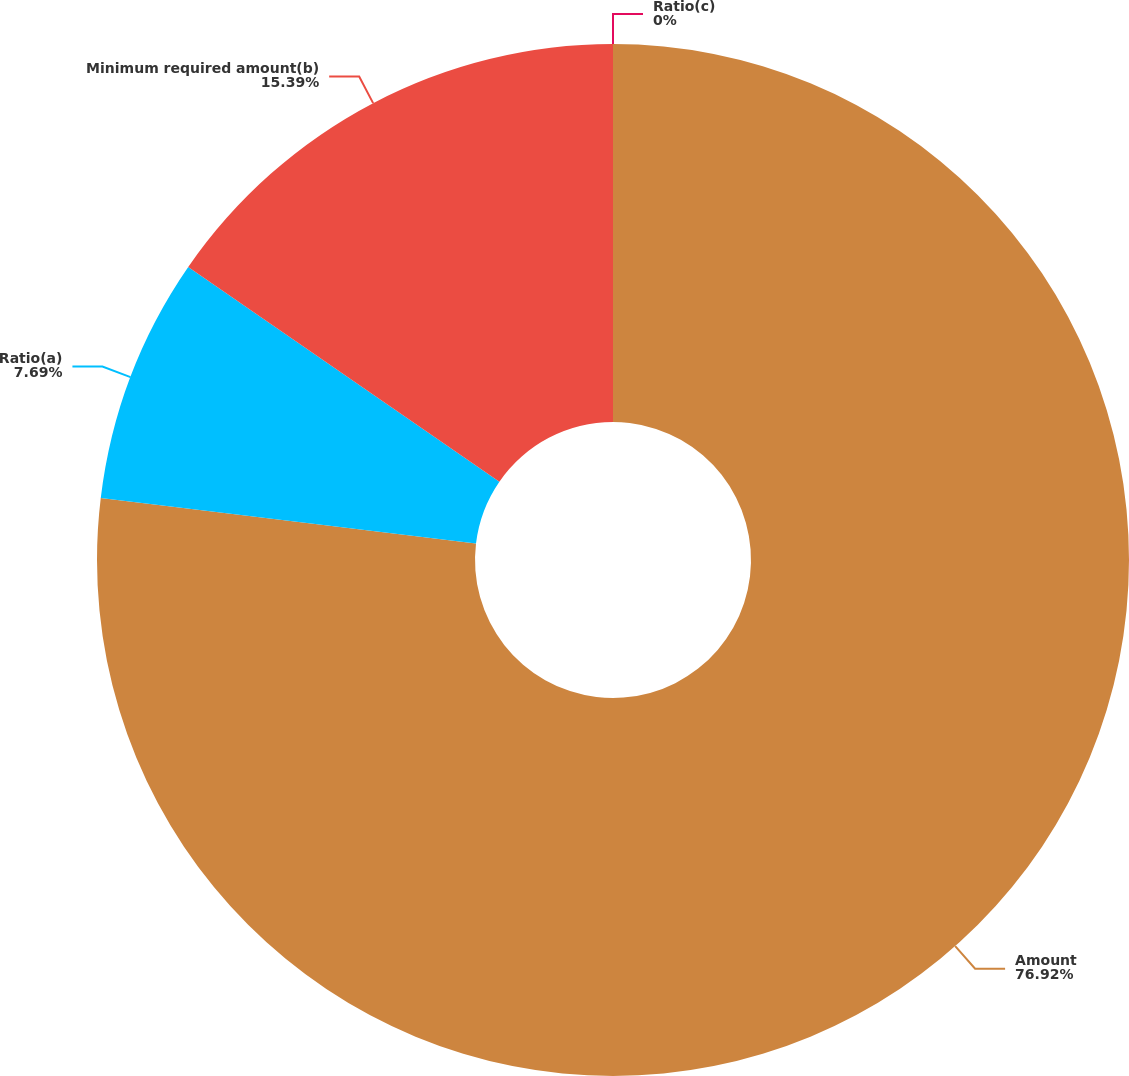Convert chart. <chart><loc_0><loc_0><loc_500><loc_500><pie_chart><fcel>Amount<fcel>Ratio(a)<fcel>Minimum required amount(b)<fcel>Ratio(c)<nl><fcel>76.92%<fcel>7.69%<fcel>15.39%<fcel>0.0%<nl></chart> 